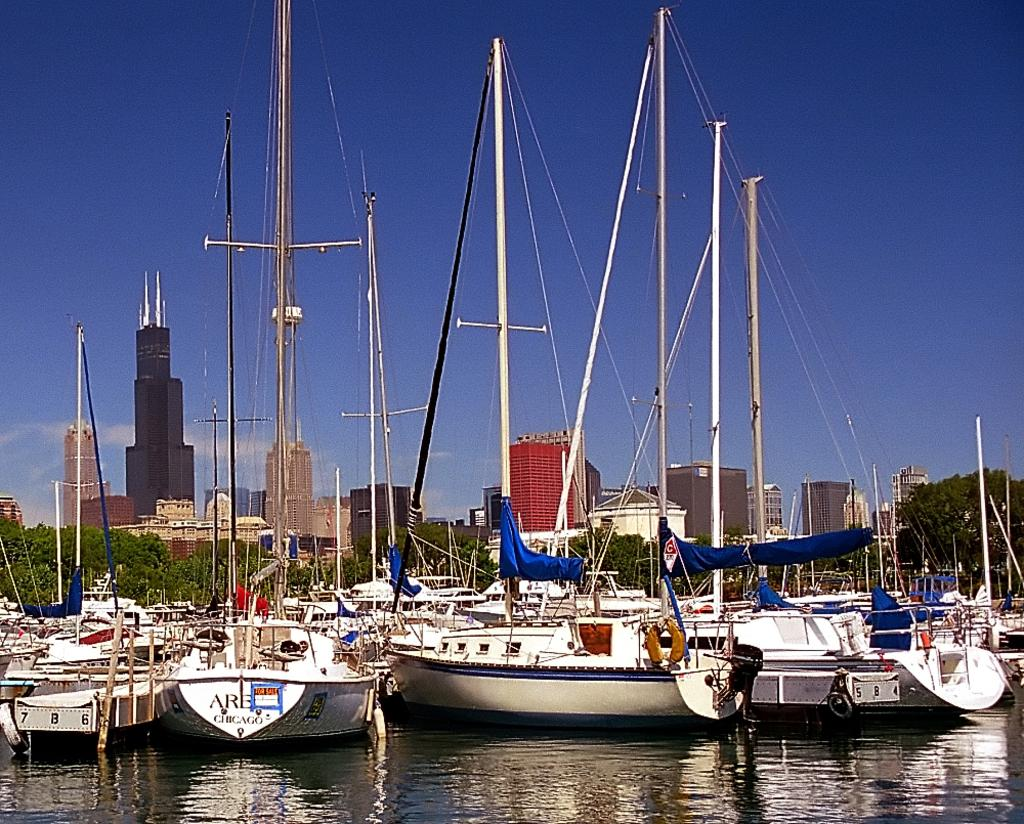<image>
Create a compact narrative representing the image presented. One of many yachts in a city harbor bears a "For Sale" sign on its stern. 